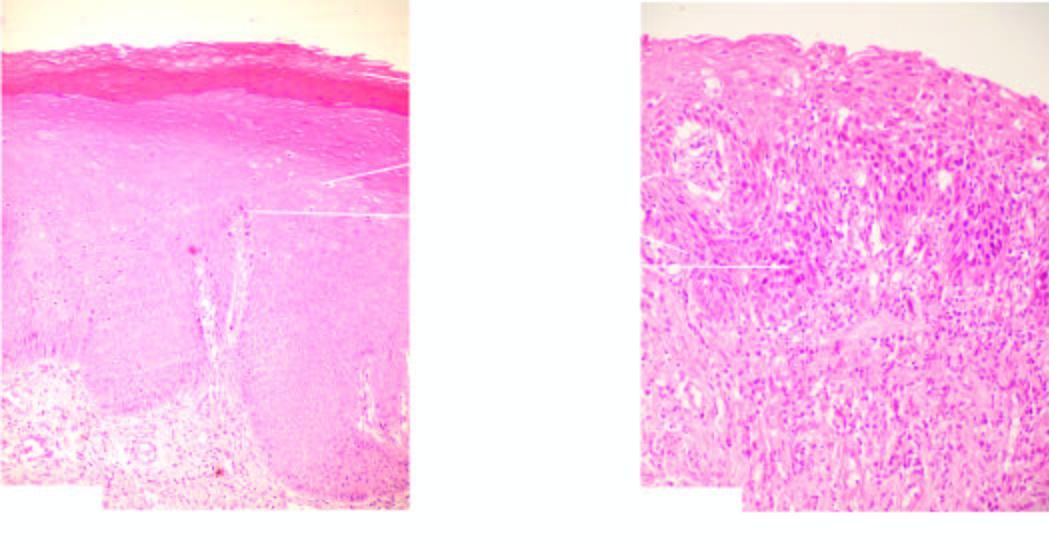what is there across the basement membrane?
Answer the question using a single word or phrase. No invasion 